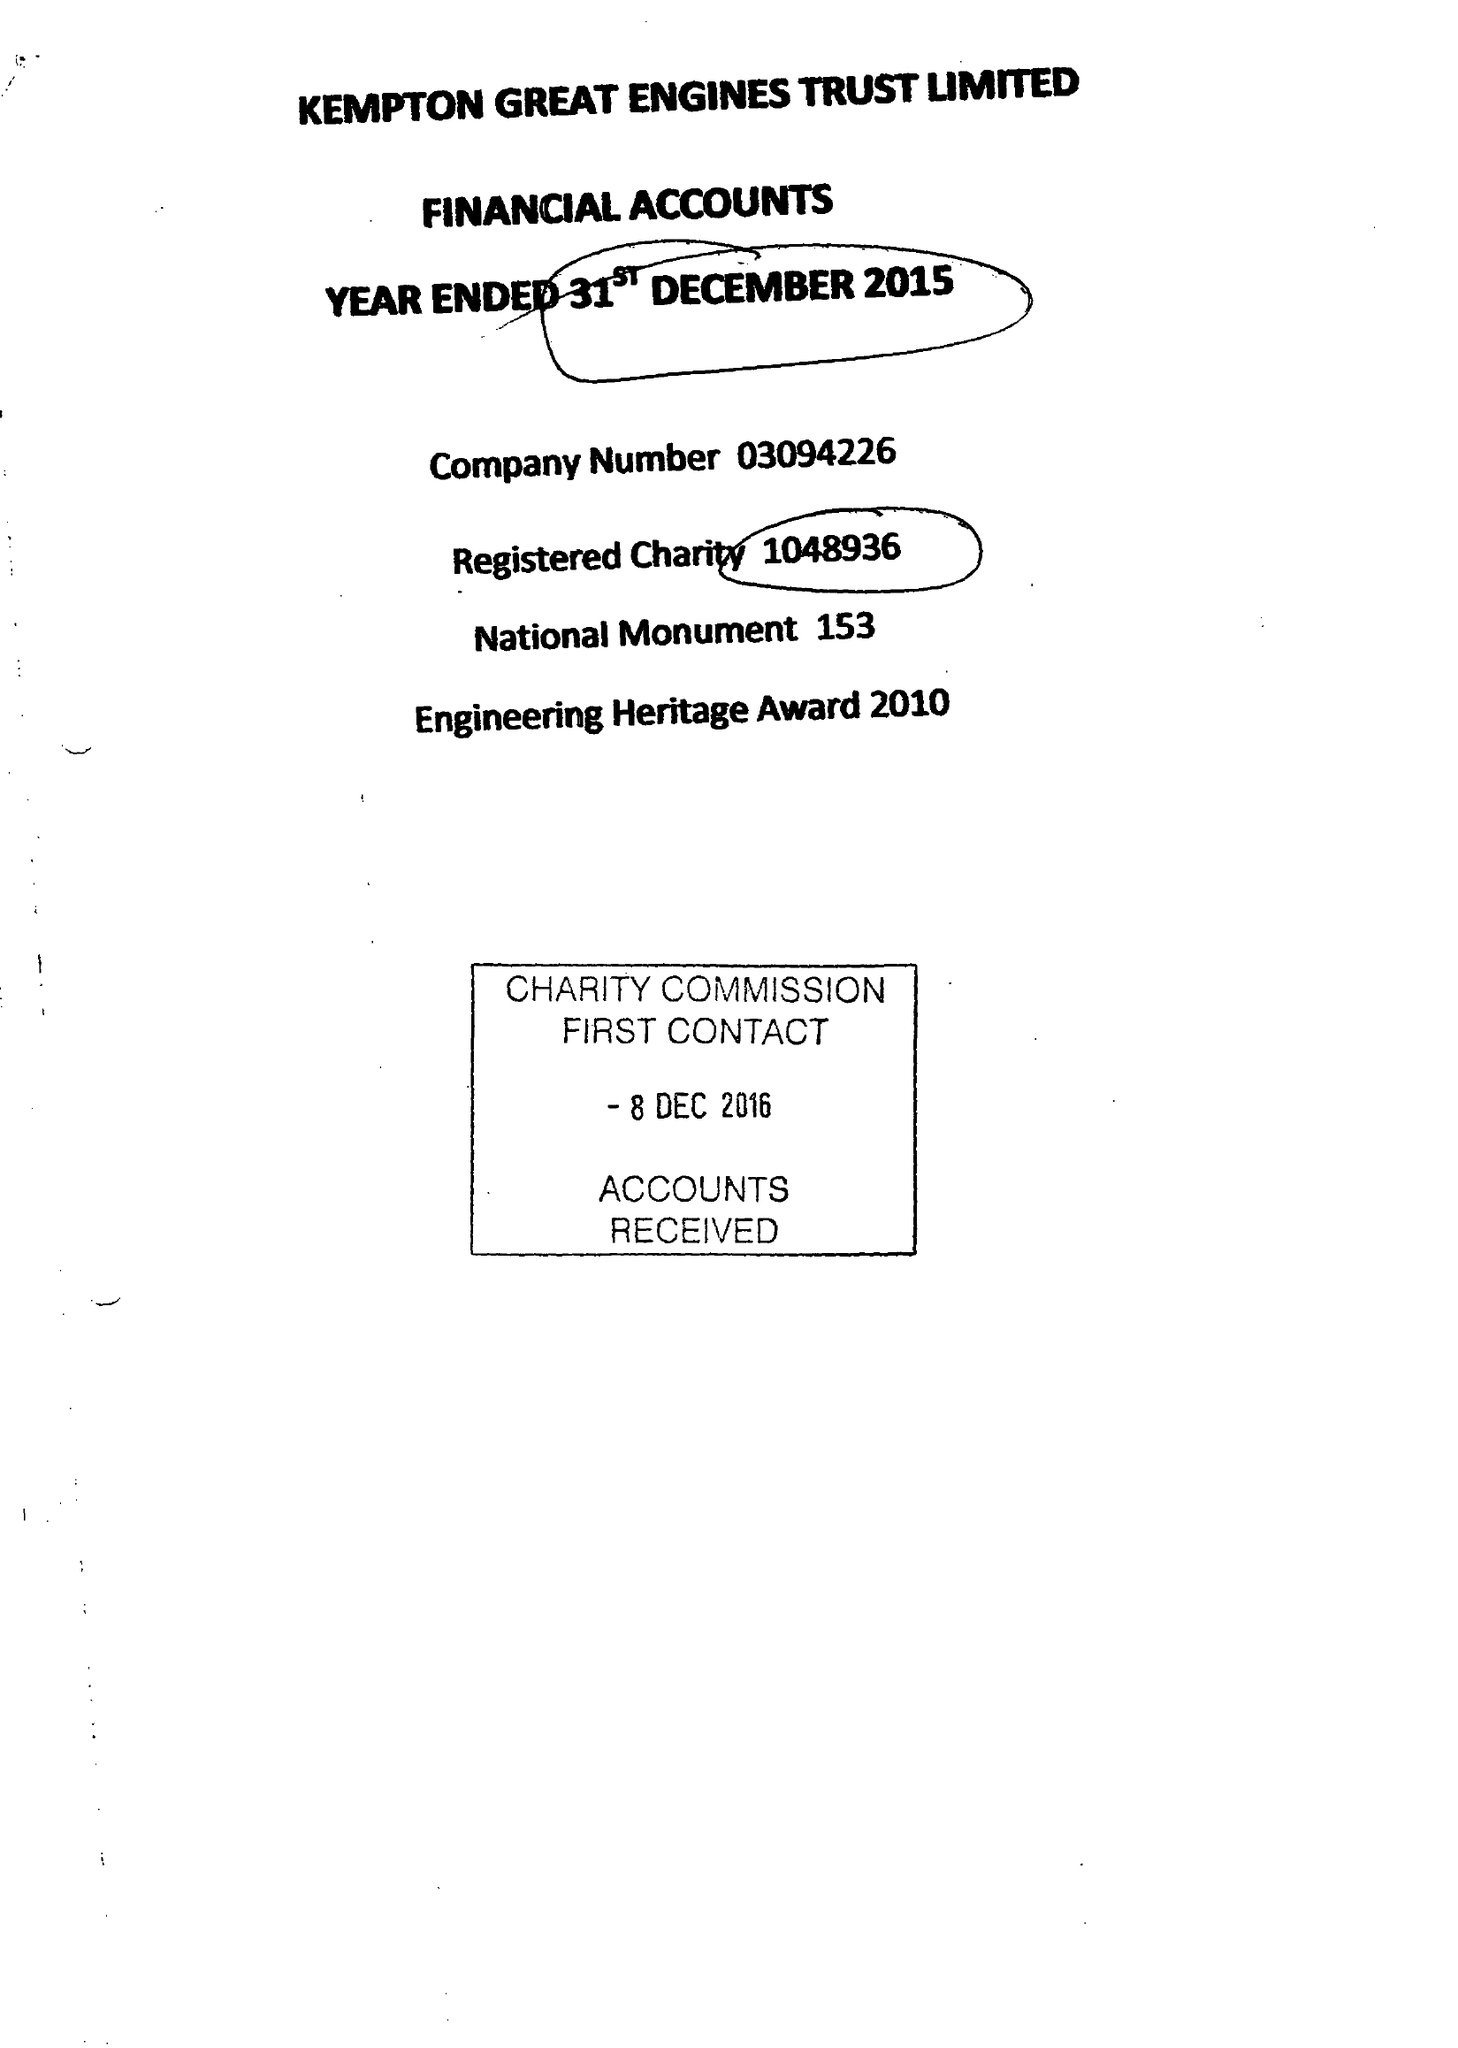What is the value for the report_date?
Answer the question using a single word or phrase. 2015-12-31 